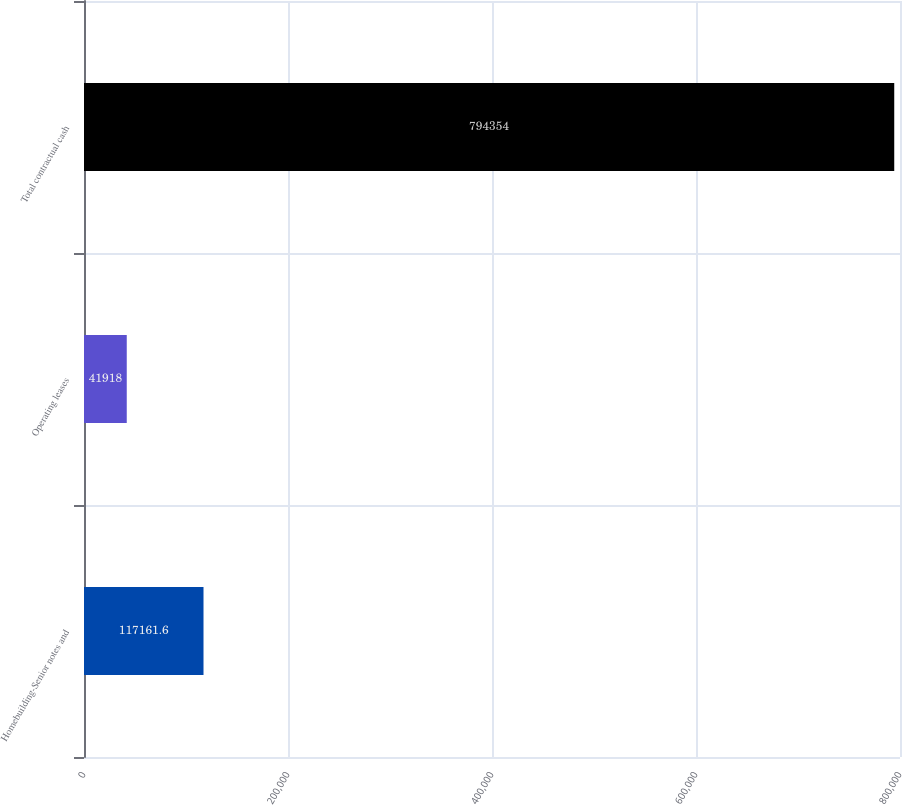Convert chart to OTSL. <chart><loc_0><loc_0><loc_500><loc_500><bar_chart><fcel>Homebuilding-Senior notes and<fcel>Operating leases<fcel>Total contractual cash<nl><fcel>117162<fcel>41918<fcel>794354<nl></chart> 